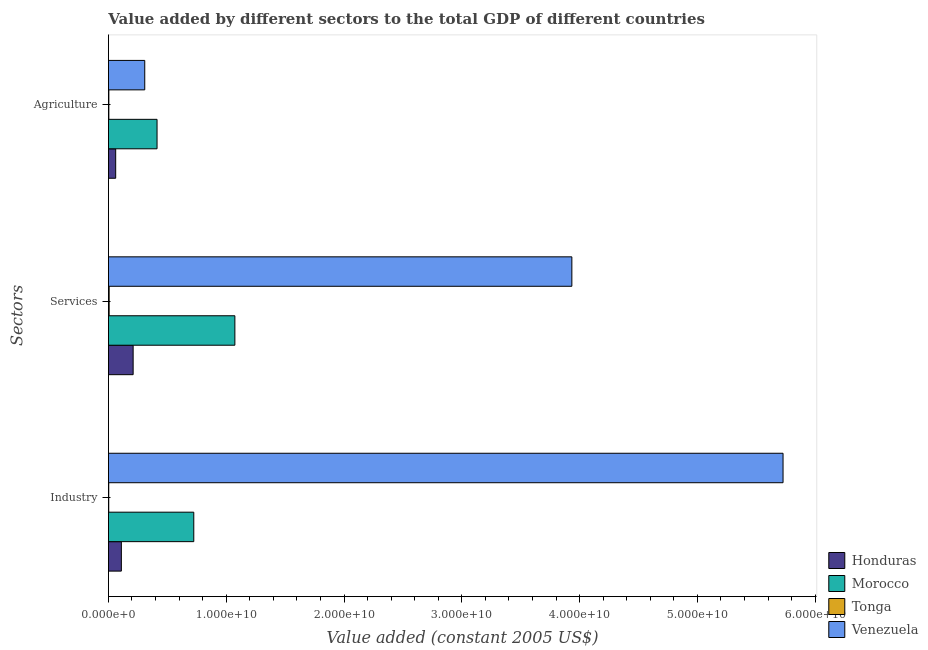Are the number of bars on each tick of the Y-axis equal?
Your answer should be compact. Yes. How many bars are there on the 3rd tick from the top?
Ensure brevity in your answer.  4. What is the label of the 2nd group of bars from the top?
Provide a short and direct response. Services. What is the value added by industrial sector in Tonga?
Provide a short and direct response. 2.66e+07. Across all countries, what is the maximum value added by agricultural sector?
Make the answer very short. 4.13e+09. Across all countries, what is the minimum value added by agricultural sector?
Keep it short and to the point. 3.71e+07. In which country was the value added by agricultural sector maximum?
Keep it short and to the point. Morocco. In which country was the value added by services minimum?
Make the answer very short. Tonga. What is the total value added by industrial sector in the graph?
Your answer should be compact. 6.56e+1. What is the difference between the value added by agricultural sector in Tonga and that in Venezuela?
Your response must be concise. -3.05e+09. What is the difference between the value added by industrial sector in Venezuela and the value added by services in Honduras?
Keep it short and to the point. 5.52e+1. What is the average value added by agricultural sector per country?
Ensure brevity in your answer.  1.97e+09. What is the difference between the value added by industrial sector and value added by agricultural sector in Venezuela?
Ensure brevity in your answer.  5.42e+1. What is the ratio of the value added by services in Venezuela to that in Honduras?
Your answer should be compact. 18.76. Is the difference between the value added by industrial sector in Tonga and Honduras greater than the difference between the value added by services in Tonga and Honduras?
Provide a short and direct response. Yes. What is the difference between the highest and the second highest value added by agricultural sector?
Your answer should be very brief. 1.05e+09. What is the difference between the highest and the lowest value added by agricultural sector?
Keep it short and to the point. 4.09e+09. Is the sum of the value added by agricultural sector in Venezuela and Tonga greater than the maximum value added by industrial sector across all countries?
Offer a very short reply. No. What does the 3rd bar from the top in Services represents?
Keep it short and to the point. Morocco. What does the 2nd bar from the bottom in Industry represents?
Give a very brief answer. Morocco. How many bars are there?
Offer a very short reply. 12. Are all the bars in the graph horizontal?
Offer a terse response. Yes. What is the difference between two consecutive major ticks on the X-axis?
Provide a succinct answer. 1.00e+1. Does the graph contain any zero values?
Give a very brief answer. No. Where does the legend appear in the graph?
Your response must be concise. Bottom right. How many legend labels are there?
Your response must be concise. 4. How are the legend labels stacked?
Provide a succinct answer. Vertical. What is the title of the graph?
Your response must be concise. Value added by different sectors to the total GDP of different countries. Does "Jamaica" appear as one of the legend labels in the graph?
Keep it short and to the point. No. What is the label or title of the X-axis?
Keep it short and to the point. Value added (constant 2005 US$). What is the label or title of the Y-axis?
Your answer should be very brief. Sectors. What is the Value added (constant 2005 US$) of Honduras in Industry?
Keep it short and to the point. 1.10e+09. What is the Value added (constant 2005 US$) in Morocco in Industry?
Give a very brief answer. 7.25e+09. What is the Value added (constant 2005 US$) of Tonga in Industry?
Your answer should be compact. 2.66e+07. What is the Value added (constant 2005 US$) in Venezuela in Industry?
Your response must be concise. 5.73e+1. What is the Value added (constant 2005 US$) in Honduras in Services?
Make the answer very short. 2.10e+09. What is the Value added (constant 2005 US$) in Morocco in Services?
Your response must be concise. 1.07e+1. What is the Value added (constant 2005 US$) of Tonga in Services?
Your response must be concise. 6.19e+07. What is the Value added (constant 2005 US$) in Venezuela in Services?
Ensure brevity in your answer.  3.93e+1. What is the Value added (constant 2005 US$) of Honduras in Agriculture?
Provide a succinct answer. 6.16e+08. What is the Value added (constant 2005 US$) in Morocco in Agriculture?
Your answer should be compact. 4.13e+09. What is the Value added (constant 2005 US$) of Tonga in Agriculture?
Make the answer very short. 3.71e+07. What is the Value added (constant 2005 US$) in Venezuela in Agriculture?
Offer a terse response. 3.08e+09. Across all Sectors, what is the maximum Value added (constant 2005 US$) in Honduras?
Your response must be concise. 2.10e+09. Across all Sectors, what is the maximum Value added (constant 2005 US$) of Morocco?
Your answer should be very brief. 1.07e+1. Across all Sectors, what is the maximum Value added (constant 2005 US$) in Tonga?
Ensure brevity in your answer.  6.19e+07. Across all Sectors, what is the maximum Value added (constant 2005 US$) in Venezuela?
Your response must be concise. 5.73e+1. Across all Sectors, what is the minimum Value added (constant 2005 US$) in Honduras?
Your answer should be very brief. 6.16e+08. Across all Sectors, what is the minimum Value added (constant 2005 US$) in Morocco?
Offer a terse response. 4.13e+09. Across all Sectors, what is the minimum Value added (constant 2005 US$) in Tonga?
Keep it short and to the point. 2.66e+07. Across all Sectors, what is the minimum Value added (constant 2005 US$) of Venezuela?
Make the answer very short. 3.08e+09. What is the total Value added (constant 2005 US$) in Honduras in the graph?
Keep it short and to the point. 3.81e+09. What is the total Value added (constant 2005 US$) in Morocco in the graph?
Give a very brief answer. 2.21e+1. What is the total Value added (constant 2005 US$) of Tonga in the graph?
Your answer should be compact. 1.26e+08. What is the total Value added (constant 2005 US$) in Venezuela in the graph?
Your response must be concise. 9.97e+1. What is the difference between the Value added (constant 2005 US$) of Honduras in Industry and that in Services?
Offer a very short reply. -1.00e+09. What is the difference between the Value added (constant 2005 US$) of Morocco in Industry and that in Services?
Provide a short and direct response. -3.49e+09. What is the difference between the Value added (constant 2005 US$) in Tonga in Industry and that in Services?
Keep it short and to the point. -3.53e+07. What is the difference between the Value added (constant 2005 US$) in Venezuela in Industry and that in Services?
Provide a succinct answer. 1.79e+1. What is the difference between the Value added (constant 2005 US$) in Honduras in Industry and that in Agriculture?
Provide a succinct answer. 4.82e+08. What is the difference between the Value added (constant 2005 US$) in Morocco in Industry and that in Agriculture?
Offer a very short reply. 3.12e+09. What is the difference between the Value added (constant 2005 US$) in Tonga in Industry and that in Agriculture?
Keep it short and to the point. -1.05e+07. What is the difference between the Value added (constant 2005 US$) of Venezuela in Industry and that in Agriculture?
Provide a succinct answer. 5.42e+1. What is the difference between the Value added (constant 2005 US$) of Honduras in Services and that in Agriculture?
Provide a short and direct response. 1.48e+09. What is the difference between the Value added (constant 2005 US$) in Morocco in Services and that in Agriculture?
Give a very brief answer. 6.61e+09. What is the difference between the Value added (constant 2005 US$) of Tonga in Services and that in Agriculture?
Offer a very short reply. 2.49e+07. What is the difference between the Value added (constant 2005 US$) of Venezuela in Services and that in Agriculture?
Your response must be concise. 3.63e+1. What is the difference between the Value added (constant 2005 US$) of Honduras in Industry and the Value added (constant 2005 US$) of Morocco in Services?
Give a very brief answer. -9.64e+09. What is the difference between the Value added (constant 2005 US$) of Honduras in Industry and the Value added (constant 2005 US$) of Tonga in Services?
Provide a short and direct response. 1.04e+09. What is the difference between the Value added (constant 2005 US$) in Honduras in Industry and the Value added (constant 2005 US$) in Venezuela in Services?
Provide a short and direct response. -3.82e+1. What is the difference between the Value added (constant 2005 US$) in Morocco in Industry and the Value added (constant 2005 US$) in Tonga in Services?
Provide a succinct answer. 7.18e+09. What is the difference between the Value added (constant 2005 US$) of Morocco in Industry and the Value added (constant 2005 US$) of Venezuela in Services?
Your answer should be very brief. -3.21e+1. What is the difference between the Value added (constant 2005 US$) in Tonga in Industry and the Value added (constant 2005 US$) in Venezuela in Services?
Your answer should be compact. -3.93e+1. What is the difference between the Value added (constant 2005 US$) of Honduras in Industry and the Value added (constant 2005 US$) of Morocco in Agriculture?
Keep it short and to the point. -3.03e+09. What is the difference between the Value added (constant 2005 US$) in Honduras in Industry and the Value added (constant 2005 US$) in Tonga in Agriculture?
Provide a short and direct response. 1.06e+09. What is the difference between the Value added (constant 2005 US$) of Honduras in Industry and the Value added (constant 2005 US$) of Venezuela in Agriculture?
Offer a terse response. -1.98e+09. What is the difference between the Value added (constant 2005 US$) of Morocco in Industry and the Value added (constant 2005 US$) of Tonga in Agriculture?
Make the answer very short. 7.21e+09. What is the difference between the Value added (constant 2005 US$) of Morocco in Industry and the Value added (constant 2005 US$) of Venezuela in Agriculture?
Offer a terse response. 4.16e+09. What is the difference between the Value added (constant 2005 US$) of Tonga in Industry and the Value added (constant 2005 US$) of Venezuela in Agriculture?
Make the answer very short. -3.06e+09. What is the difference between the Value added (constant 2005 US$) of Honduras in Services and the Value added (constant 2005 US$) of Morocco in Agriculture?
Make the answer very short. -2.03e+09. What is the difference between the Value added (constant 2005 US$) in Honduras in Services and the Value added (constant 2005 US$) in Tonga in Agriculture?
Make the answer very short. 2.06e+09. What is the difference between the Value added (constant 2005 US$) in Honduras in Services and the Value added (constant 2005 US$) in Venezuela in Agriculture?
Offer a terse response. -9.85e+08. What is the difference between the Value added (constant 2005 US$) of Morocco in Services and the Value added (constant 2005 US$) of Tonga in Agriculture?
Offer a terse response. 1.07e+1. What is the difference between the Value added (constant 2005 US$) in Morocco in Services and the Value added (constant 2005 US$) in Venezuela in Agriculture?
Ensure brevity in your answer.  7.65e+09. What is the difference between the Value added (constant 2005 US$) in Tonga in Services and the Value added (constant 2005 US$) in Venezuela in Agriculture?
Give a very brief answer. -3.02e+09. What is the average Value added (constant 2005 US$) in Honduras per Sectors?
Provide a succinct answer. 1.27e+09. What is the average Value added (constant 2005 US$) of Morocco per Sectors?
Your answer should be compact. 7.37e+09. What is the average Value added (constant 2005 US$) in Tonga per Sectors?
Make the answer very short. 4.19e+07. What is the average Value added (constant 2005 US$) of Venezuela per Sectors?
Provide a succinct answer. 3.32e+1. What is the difference between the Value added (constant 2005 US$) of Honduras and Value added (constant 2005 US$) of Morocco in Industry?
Offer a terse response. -6.15e+09. What is the difference between the Value added (constant 2005 US$) in Honduras and Value added (constant 2005 US$) in Tonga in Industry?
Offer a terse response. 1.07e+09. What is the difference between the Value added (constant 2005 US$) of Honduras and Value added (constant 2005 US$) of Venezuela in Industry?
Ensure brevity in your answer.  -5.62e+1. What is the difference between the Value added (constant 2005 US$) in Morocco and Value added (constant 2005 US$) in Tonga in Industry?
Provide a succinct answer. 7.22e+09. What is the difference between the Value added (constant 2005 US$) in Morocco and Value added (constant 2005 US$) in Venezuela in Industry?
Offer a very short reply. -5.00e+1. What is the difference between the Value added (constant 2005 US$) in Tonga and Value added (constant 2005 US$) in Venezuela in Industry?
Offer a very short reply. -5.73e+1. What is the difference between the Value added (constant 2005 US$) in Honduras and Value added (constant 2005 US$) in Morocco in Services?
Ensure brevity in your answer.  -8.64e+09. What is the difference between the Value added (constant 2005 US$) of Honduras and Value added (constant 2005 US$) of Tonga in Services?
Your response must be concise. 2.04e+09. What is the difference between the Value added (constant 2005 US$) in Honduras and Value added (constant 2005 US$) in Venezuela in Services?
Offer a very short reply. -3.72e+1. What is the difference between the Value added (constant 2005 US$) in Morocco and Value added (constant 2005 US$) in Tonga in Services?
Offer a very short reply. 1.07e+1. What is the difference between the Value added (constant 2005 US$) in Morocco and Value added (constant 2005 US$) in Venezuela in Services?
Give a very brief answer. -2.86e+1. What is the difference between the Value added (constant 2005 US$) in Tonga and Value added (constant 2005 US$) in Venezuela in Services?
Ensure brevity in your answer.  -3.93e+1. What is the difference between the Value added (constant 2005 US$) of Honduras and Value added (constant 2005 US$) of Morocco in Agriculture?
Give a very brief answer. -3.51e+09. What is the difference between the Value added (constant 2005 US$) in Honduras and Value added (constant 2005 US$) in Tonga in Agriculture?
Offer a very short reply. 5.79e+08. What is the difference between the Value added (constant 2005 US$) of Honduras and Value added (constant 2005 US$) of Venezuela in Agriculture?
Provide a succinct answer. -2.47e+09. What is the difference between the Value added (constant 2005 US$) in Morocco and Value added (constant 2005 US$) in Tonga in Agriculture?
Offer a terse response. 4.09e+09. What is the difference between the Value added (constant 2005 US$) in Morocco and Value added (constant 2005 US$) in Venezuela in Agriculture?
Provide a short and direct response. 1.05e+09. What is the difference between the Value added (constant 2005 US$) of Tonga and Value added (constant 2005 US$) of Venezuela in Agriculture?
Offer a terse response. -3.05e+09. What is the ratio of the Value added (constant 2005 US$) of Honduras in Industry to that in Services?
Keep it short and to the point. 0.52. What is the ratio of the Value added (constant 2005 US$) of Morocco in Industry to that in Services?
Provide a short and direct response. 0.68. What is the ratio of the Value added (constant 2005 US$) of Tonga in Industry to that in Services?
Make the answer very short. 0.43. What is the ratio of the Value added (constant 2005 US$) of Venezuela in Industry to that in Services?
Ensure brevity in your answer.  1.46. What is the ratio of the Value added (constant 2005 US$) of Honduras in Industry to that in Agriculture?
Keep it short and to the point. 1.78. What is the ratio of the Value added (constant 2005 US$) of Morocco in Industry to that in Agriculture?
Make the answer very short. 1.76. What is the ratio of the Value added (constant 2005 US$) of Tonga in Industry to that in Agriculture?
Give a very brief answer. 0.72. What is the ratio of the Value added (constant 2005 US$) of Venezuela in Industry to that in Agriculture?
Your answer should be very brief. 18.58. What is the ratio of the Value added (constant 2005 US$) in Honduras in Services to that in Agriculture?
Provide a succinct answer. 3.4. What is the ratio of the Value added (constant 2005 US$) in Morocco in Services to that in Agriculture?
Offer a terse response. 2.6. What is the ratio of the Value added (constant 2005 US$) of Tonga in Services to that in Agriculture?
Keep it short and to the point. 1.67. What is the ratio of the Value added (constant 2005 US$) in Venezuela in Services to that in Agriculture?
Provide a succinct answer. 12.76. What is the difference between the highest and the second highest Value added (constant 2005 US$) in Honduras?
Provide a short and direct response. 1.00e+09. What is the difference between the highest and the second highest Value added (constant 2005 US$) of Morocco?
Keep it short and to the point. 3.49e+09. What is the difference between the highest and the second highest Value added (constant 2005 US$) in Tonga?
Offer a very short reply. 2.49e+07. What is the difference between the highest and the second highest Value added (constant 2005 US$) of Venezuela?
Offer a terse response. 1.79e+1. What is the difference between the highest and the lowest Value added (constant 2005 US$) in Honduras?
Provide a succinct answer. 1.48e+09. What is the difference between the highest and the lowest Value added (constant 2005 US$) in Morocco?
Provide a short and direct response. 6.61e+09. What is the difference between the highest and the lowest Value added (constant 2005 US$) of Tonga?
Give a very brief answer. 3.53e+07. What is the difference between the highest and the lowest Value added (constant 2005 US$) of Venezuela?
Provide a succinct answer. 5.42e+1. 